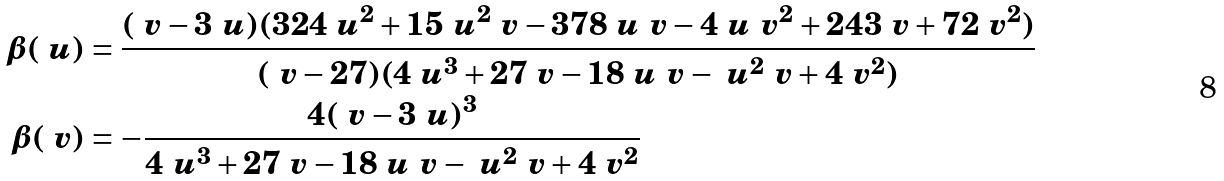<formula> <loc_0><loc_0><loc_500><loc_500>\beta ( \ u ) & = \frac { ( \ v - 3 \ u ) ( 3 2 4 \ u ^ { 2 } + 1 5 \ u ^ { 2 } \ v - 3 7 8 \ u \ v - 4 \ u \ v ^ { 2 } + 2 4 3 \ v + 7 2 \ v ^ { 2 } ) } { ( \ v - 2 7 ) ( 4 \ u ^ { 3 } + 2 7 \ v - 1 8 \ u \ v - \ u ^ { 2 } \ v + 4 \ v ^ { 2 } ) } \\ \beta ( \ v ) & = - \frac { 4 ( \ v - 3 \ u ) ^ { 3 } } { 4 \ u ^ { 3 } + 2 7 \ v - 1 8 \ u \ v - \ u ^ { 2 } \ v + 4 \ v ^ { 2 } } \\</formula> 